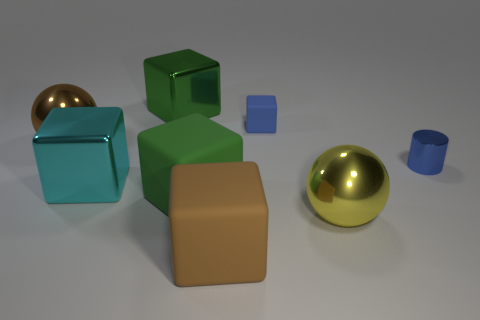What shape is the metallic thing that is the same color as the small block?
Your response must be concise. Cylinder. There is another shiny object that is the same shape as the big yellow object; what is its size?
Offer a very short reply. Large. Is there any other thing that is the same shape as the big cyan metal object?
Provide a short and direct response. Yes. Does the cyan object have the same size as the blue cube?
Your response must be concise. No. What color is the cylinder that is made of the same material as the big brown ball?
Ensure brevity in your answer.  Blue. Are there fewer large shiny cubes in front of the tiny block than small things behind the brown rubber cube?
Keep it short and to the point. Yes. What number of other small cubes are the same color as the tiny block?
Your answer should be very brief. 0. What is the material of the cylinder that is the same color as the tiny rubber block?
Make the answer very short. Metal. What number of cubes are both right of the big green metal block and in front of the big brown metal thing?
Provide a short and direct response. 2. The big cyan thing that is behind the block that is in front of the yellow thing is made of what material?
Keep it short and to the point. Metal. 